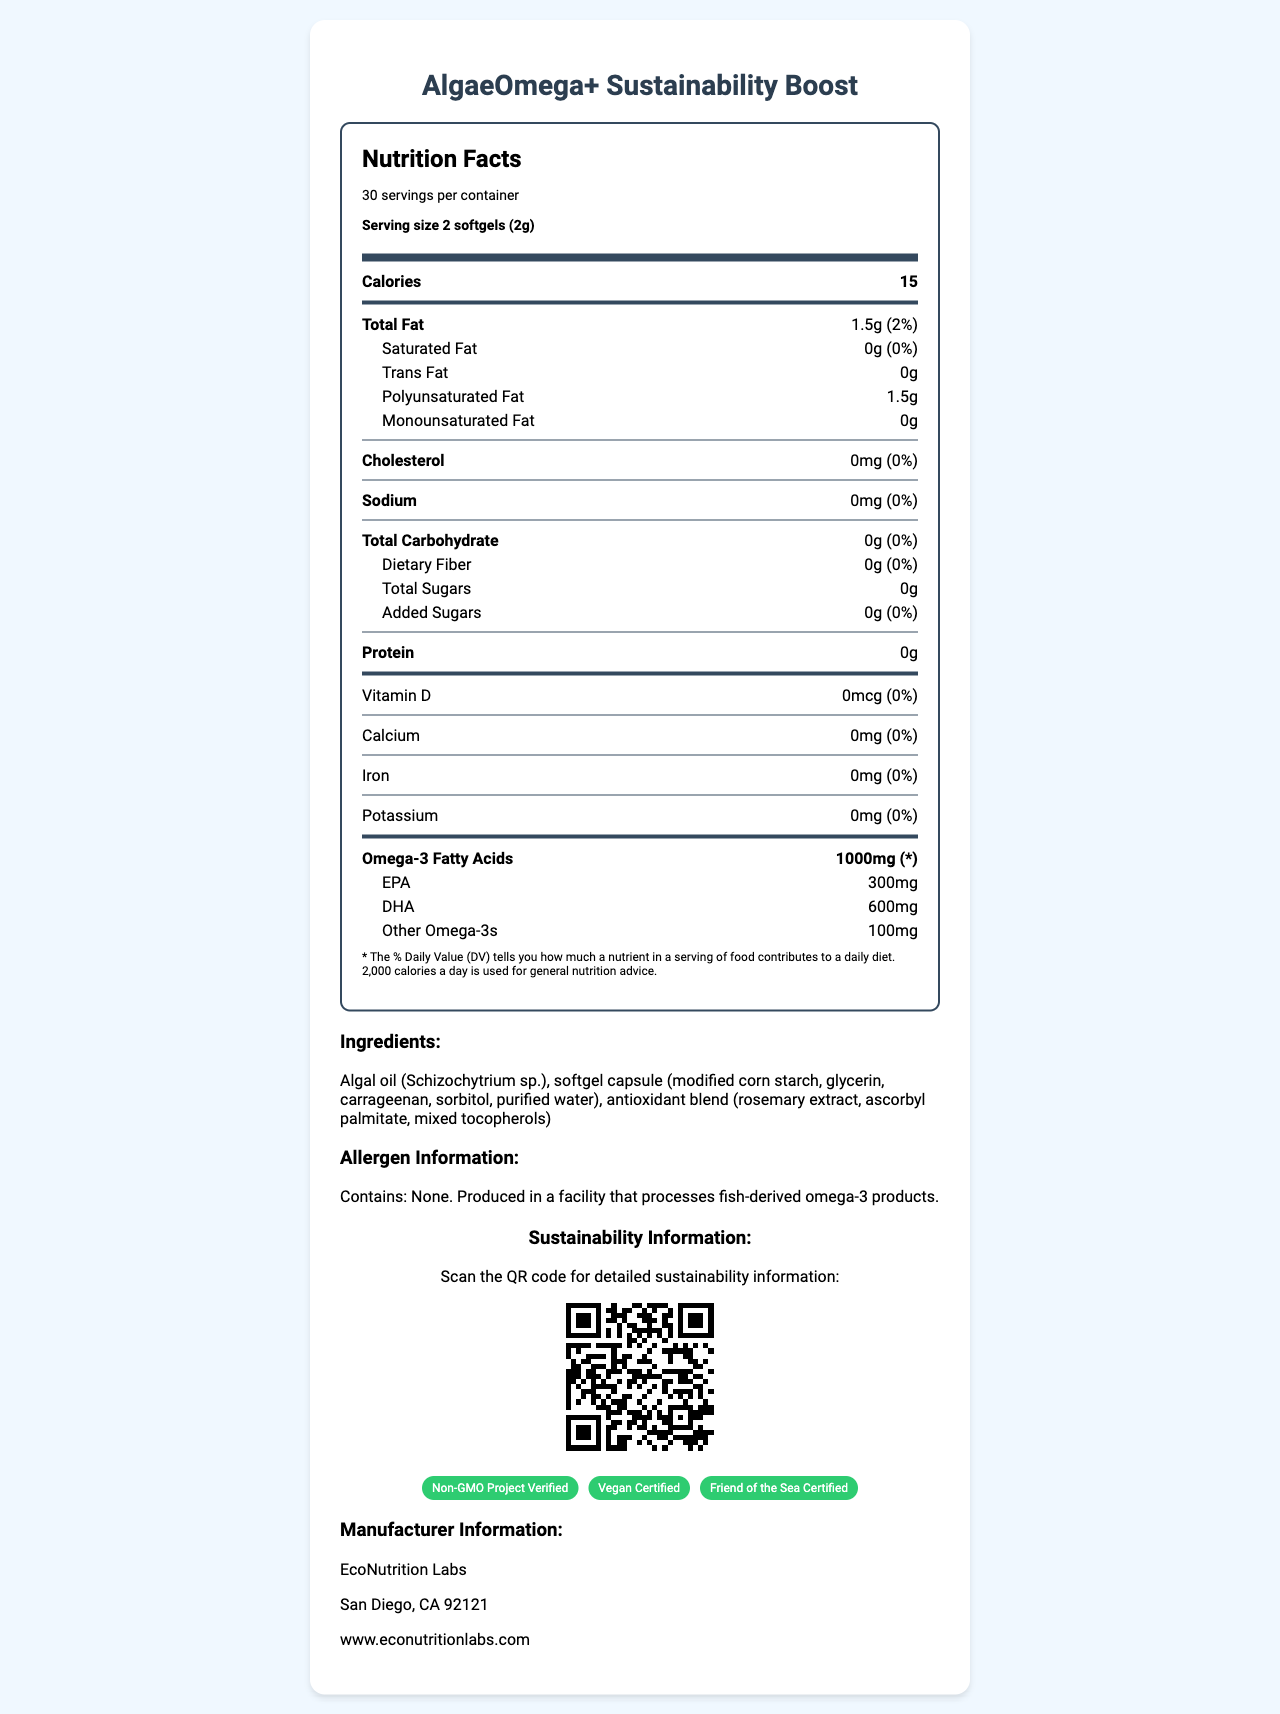what is the serving size of AlgaeOmega+ Sustainability Boost? The serving size is explicitly mentioned under the "serving size" section in the document.
Answer: 2 softgels (2g) how many servings are there in one container? The number of servings per container is listed as 30 under the "servings per container" section.
Answer: 30 how many calories are there per serving? The calories per serving are listed as 15.
Answer: 15 how much total fat does one serving contain and what is its daily value percentage? The document lists total fat as 1.5g and mentions it's 2% of the daily value.
Answer: 1.5g, 2% what types of omega-3 fatty acids are included and how much of each type is present per serving? The amounts of different types of omega-3 fatty acids are divided into EPA, DHA, and Other Omega-3s with their respective amounts.
Answer: EPA: 300mg, DHA: 600mg, Other Omega-3s: 100mg what is not present in the supplement based on the allergen information? The allergen information clearly states the product contains none and is produced in a facility that processes fish-derived omega-3 products.
Answer: Contains: None. which of these certifications does the product have? A. Gluten-Free B. Vegan Certified C. Organic Certified D. Non-GMO Project Verified The product includes certifications for "Non-GMO Project Verified" and "Vegan Certified."
Answer: B, D how much polyunsaturated fat is in a serving? The amount of polyunsaturated fat per serving is listed as 1.5g.
Answer: 1.5g true or false: The supplement contains added sugars. The document explicitly states that the supplement contains 0g of added sugars.
Answer: False who manufactures the AlgaeOmega+ Sustainability Boost? The manufacturer information section lists EcoNutrition Labs as the manufacturer.
Answer: EcoNutrition Labs what are some potential ingredients in the antioxidant blend? A. Green Tea Extract B. Rosemary Extract C. Ascorbyl Palmitate D. Mixed Tocopherols The antioxidant blend includes rosemary extract, ascorbyl palmitate, and mixed tocopherols.
Answer: B, C, D summarize the main purpose of this document. The document serves to inform consumers about the nutritional content and sustainability efforts behind the AlgaeOmega+ product while also promoting its certifications and eco-friendly attributes.
Answer: The document provides detailed nutritional information for the AlgaeOmega+ Sustainability Boost, an eco-friendly, algae-based omega-3 supplement. It includes data on serving size, calories, fats, and other nutrients. It also highlights the sustainability features with a QR code for more information, certifications, ingredient list, allergen information, and manufacturer details. how is the sustainability information accessed? The document includes a QR code that links to detailed sustainability information.
Answer: By scanning the QR code what is the daily value percentage for protein in the supplement? The daily value percentage for protein is listed as 0%, indicating no relevant amount of protein.
Answer: 0% is this product considered allergen-free? While the product itself contains no allergens, it is produced in a facility that processes fish-derived omega-3 products; therefore, cross-contamination risk cannot be entirely ruled out.
Answer: Cannot be determined what type of fiber is included and how much is present per serving? The document states that dietary fiber per serving is 0g.
Answer: Dietary Fiber: 0g 